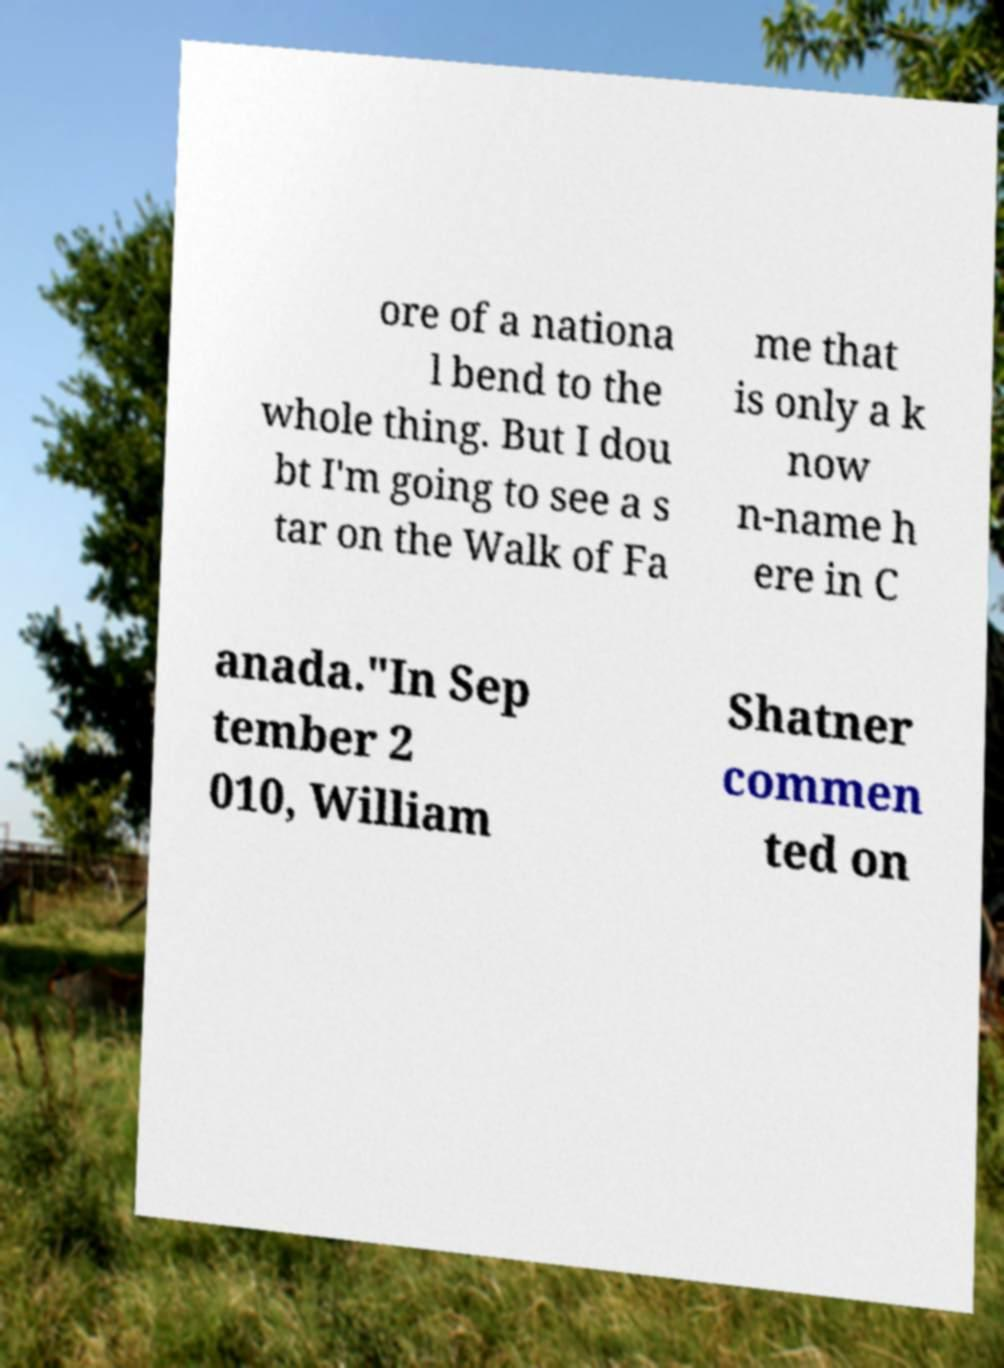Can you read and provide the text displayed in the image?This photo seems to have some interesting text. Can you extract and type it out for me? ore of a nationa l bend to the whole thing. But I dou bt I'm going to see a s tar on the Walk of Fa me that is only a k now n-name h ere in C anada."In Sep tember 2 010, William Shatner commen ted on 